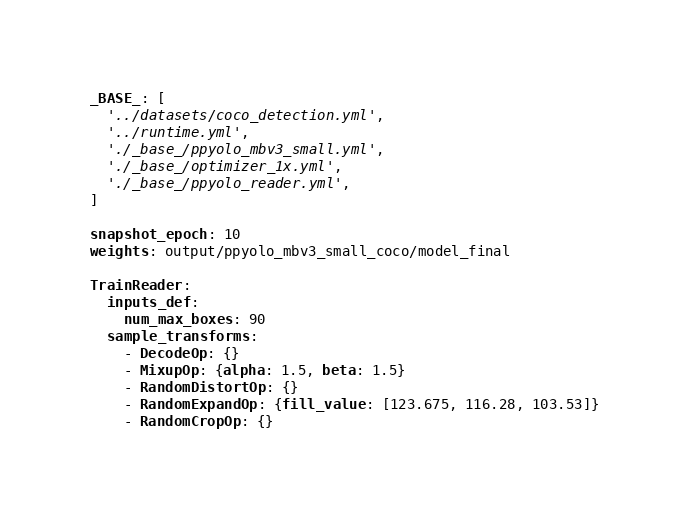<code> <loc_0><loc_0><loc_500><loc_500><_YAML_>_BASE_: [
  '../datasets/coco_detection.yml',
  '../runtime.yml',
  './_base_/ppyolo_mbv3_small.yml',
  './_base_/optimizer_1x.yml',
  './_base_/ppyolo_reader.yml',
]

snapshot_epoch: 10
weights: output/ppyolo_mbv3_small_coco/model_final

TrainReader:
  inputs_def:
    num_max_boxes: 90
  sample_transforms:
    - DecodeOp: {}
    - MixupOp: {alpha: 1.5, beta: 1.5}
    - RandomDistortOp: {}
    - RandomExpandOp: {fill_value: [123.675, 116.28, 103.53]}
    - RandomCropOp: {}</code> 